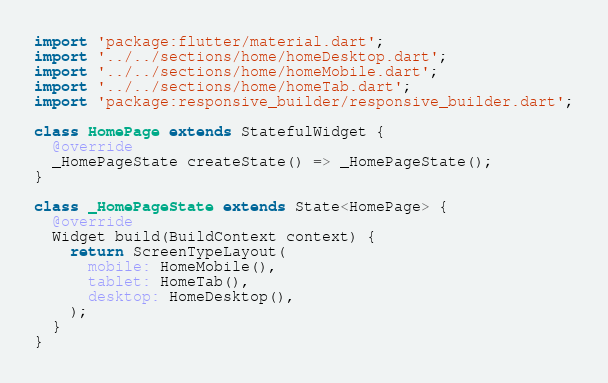<code> <loc_0><loc_0><loc_500><loc_500><_Dart_>import 'package:flutter/material.dart';
import '../../sections/home/homeDesktop.dart';
import '../../sections/home/homeMobile.dart';
import '../../sections/home/homeTab.dart';
import 'package:responsive_builder/responsive_builder.dart';

class HomePage extends StatefulWidget {
  @override
  _HomePageState createState() => _HomePageState();
}

class _HomePageState extends State<HomePage> {
  @override
  Widget build(BuildContext context) {
    return ScreenTypeLayout(
      mobile: HomeMobile(),
      tablet: HomeTab(),
      desktop: HomeDesktop(),
    );
  }
}
</code> 